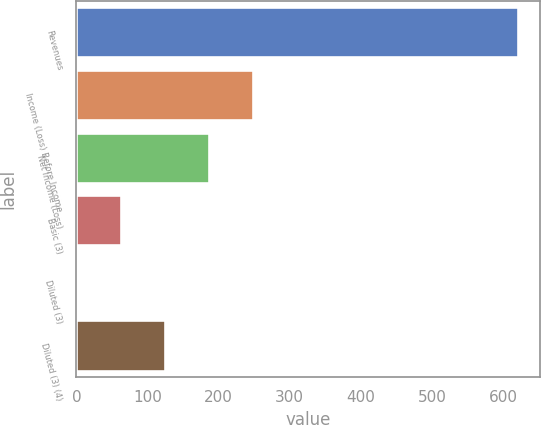Convert chart. <chart><loc_0><loc_0><loc_500><loc_500><bar_chart><fcel>Revenues<fcel>Income (Loss) Before Income<fcel>Net Income (Loss)<fcel>Basic (3)<fcel>Diluted (3)<fcel>Diluted (3) (4)<nl><fcel>621<fcel>248.77<fcel>186.73<fcel>62.65<fcel>0.61<fcel>124.69<nl></chart> 